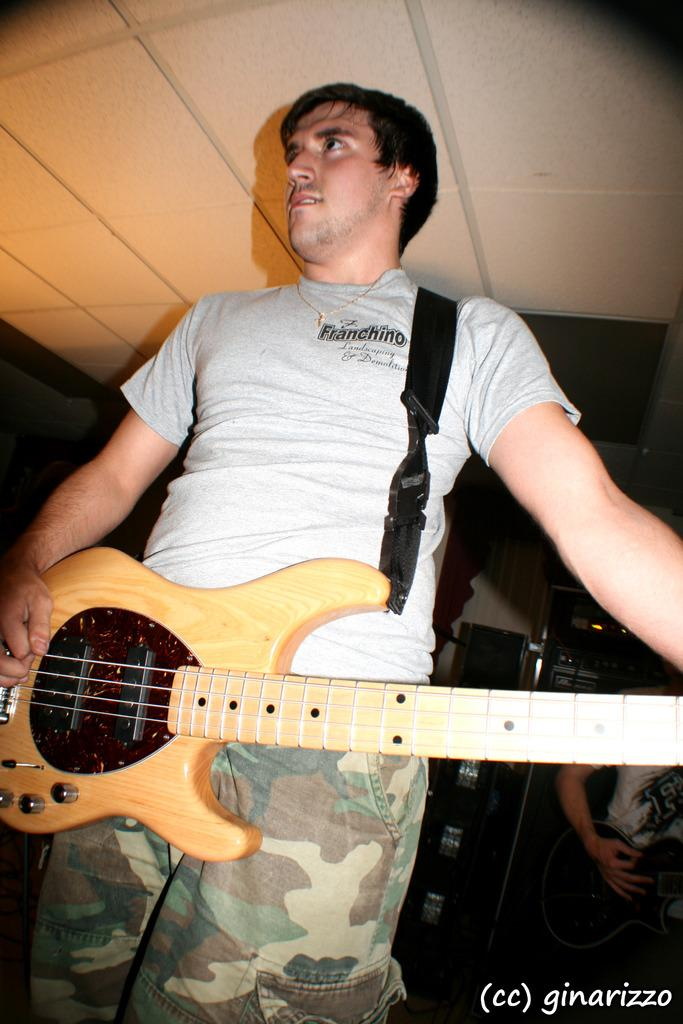How many people are in the image? There are two persons in the image. What are the persons holding in their hands? Both persons are holding guitars in their hands. What type of harmony can be heard between the two guitars in the image? There is no sound in the image, so it is not possible to determine the harmony between the two guitars. 